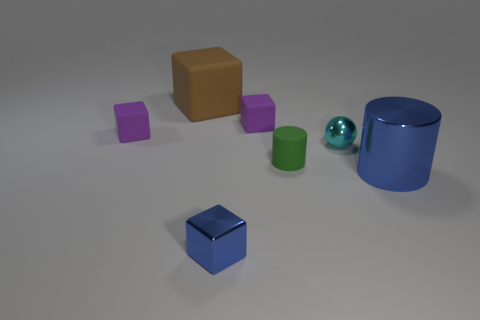Subtract all metallic blocks. How many blocks are left? 3 Subtract all purple blocks. How many blocks are left? 2 Subtract all purple spheres. How many purple cubes are left? 2 Add 2 tiny yellow things. How many objects exist? 9 Subtract all blocks. How many objects are left? 3 Subtract 2 cubes. How many cubes are left? 2 Add 2 big rubber things. How many big rubber things exist? 3 Subtract 1 cyan spheres. How many objects are left? 6 Subtract all red cylinders. Subtract all red spheres. How many cylinders are left? 2 Subtract all large blue blocks. Subtract all brown cubes. How many objects are left? 6 